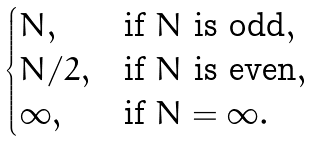<formula> <loc_0><loc_0><loc_500><loc_500>\begin{cases} N , & \text {if } N \text { is odd} , \\ N / 2 , & \text {if } N \text { is even} , \\ \infty , & \text {if } N = \infty . \end{cases}</formula> 